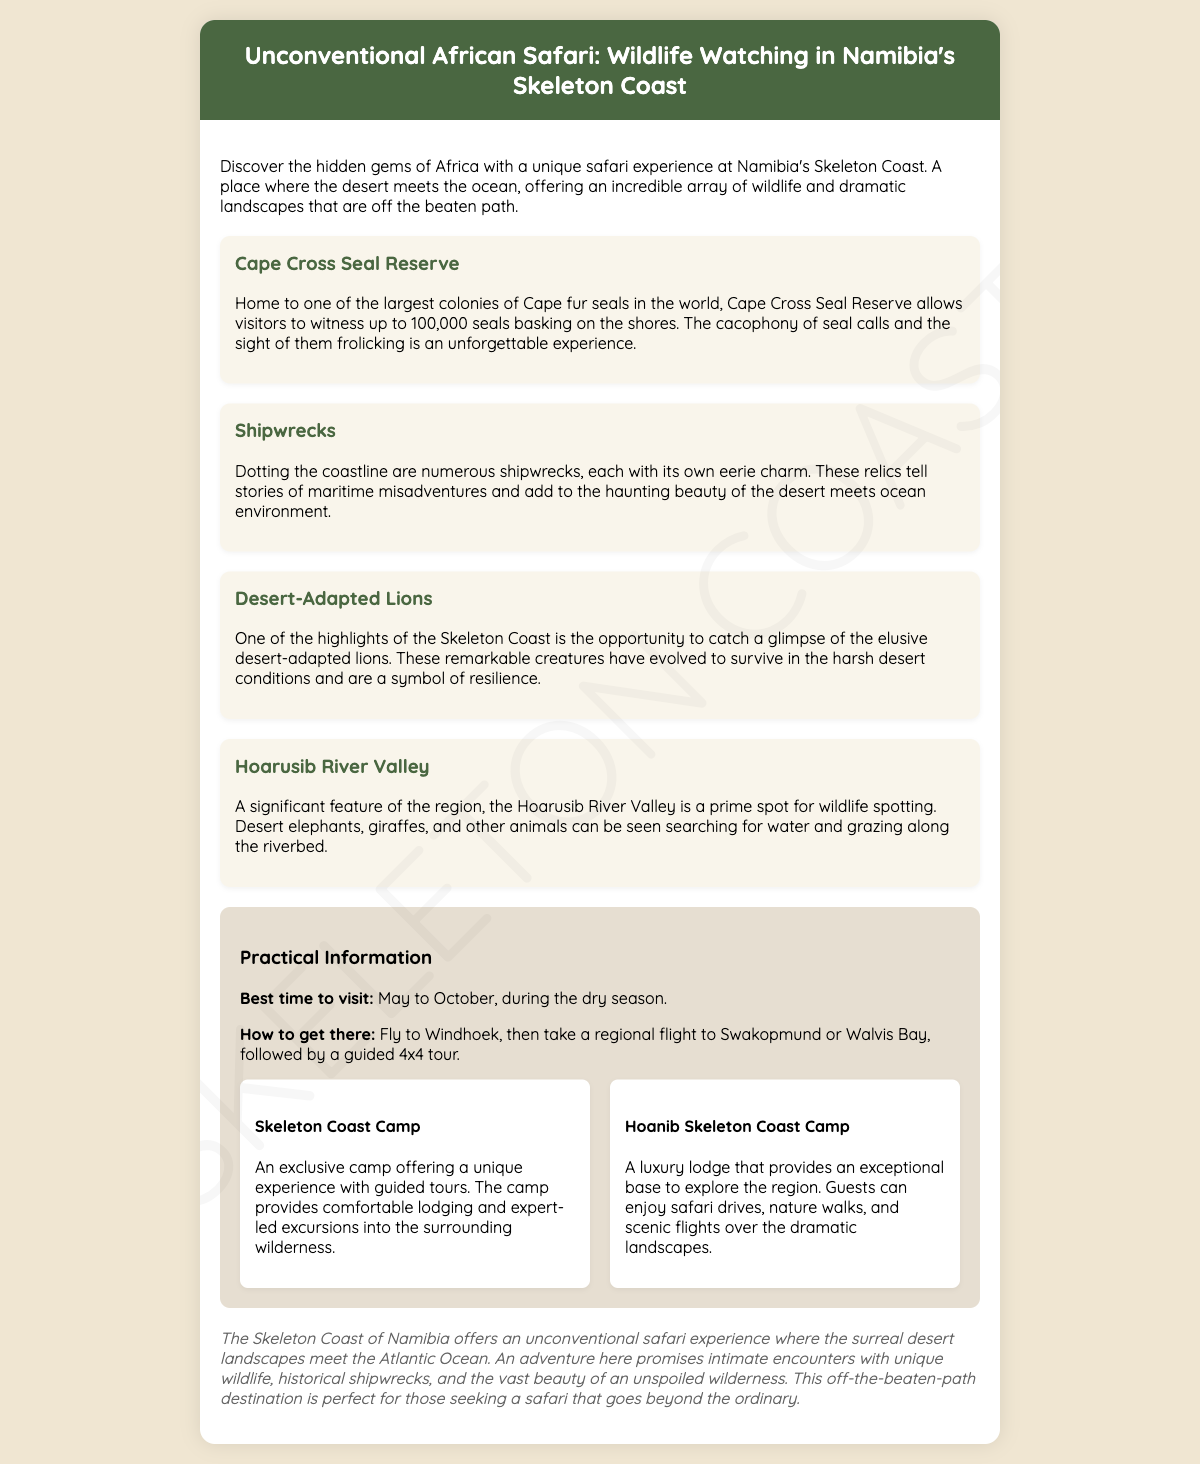What is the main activity in Namibia's Skeleton Coast? The document mentions a unique safari experience as the main activity in the Skeleton Coast.
Answer: Safari experience What is the best time to visit? The best time mentioned in the document is between May to October, during the dry season.
Answer: May to October How many Cape fur seals can be seen at Cape Cross Seal Reserve? The passage states visitors can witness up to 100,000 seals at the reserve.
Answer: Up to 100,000 What types of accommodation are mentioned? The document lists "Skeleton Coast Camp" and "Hoanib Skeleton Coast Camp" as the types of accommodation.
Answer: Skeleton Coast Camp, Hoanib Skeleton Coast Camp What unique wildlife can be spotted in the Hoarusib River Valley? The document mentions desert elephants and giraffes are often seen in this region.
Answer: Desert elephants, giraffes Why is the Skeleton Coast described as unconventional? The description implies that the mix of surreal desert landscapes and ocean is what makes it unconventional.
Answer: Desert landscapes meet the ocean What features add to the beauty of the Skeleton Coast? The document references numerous shipwrecks and dramatic landscapes as features of beauty.
Answer: Shipwrecks, dramatic landscapes How can one get to Skeleton Coast? According to the document, travel involves flying to Windhoek, then taking a regional flight to Swakopmund or Walvis Bay.
Answer: Fly to Windhoek, regional flight to Swakopmund or Walvis Bay 